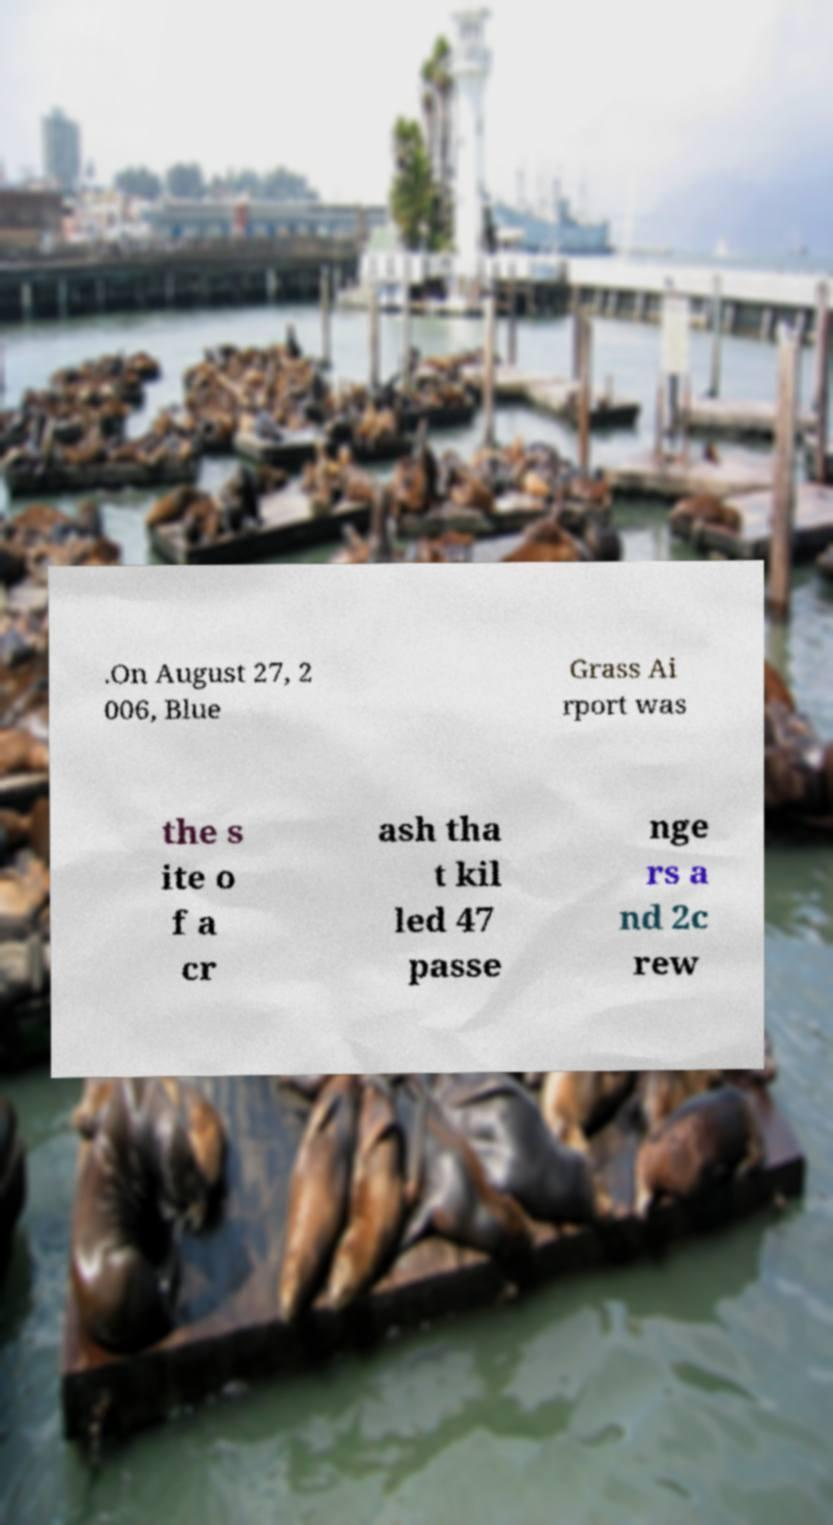For documentation purposes, I need the text within this image transcribed. Could you provide that? .On August 27, 2 006, Blue Grass Ai rport was the s ite o f a cr ash tha t kil led 47 passe nge rs a nd 2c rew 